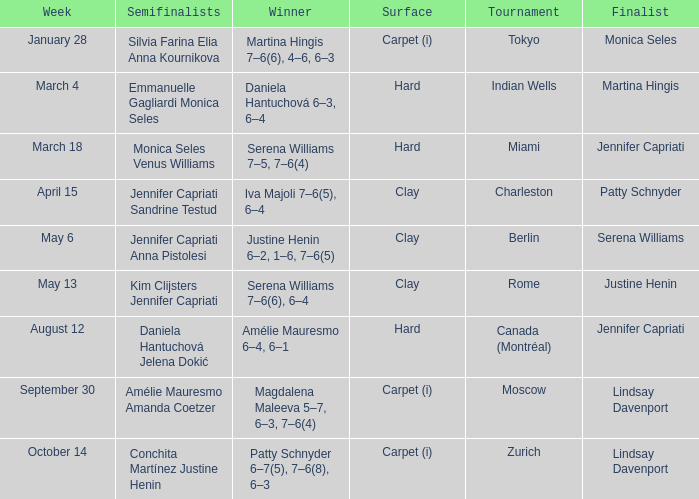What was the surface for finalist Justine Henin? Clay. 